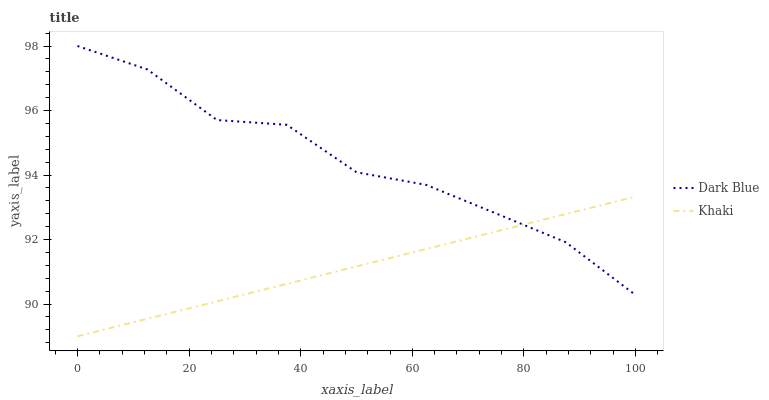Does Khaki have the minimum area under the curve?
Answer yes or no. Yes. Does Dark Blue have the maximum area under the curve?
Answer yes or no. Yes. Does Khaki have the maximum area under the curve?
Answer yes or no. No. Is Khaki the smoothest?
Answer yes or no. Yes. Is Dark Blue the roughest?
Answer yes or no. Yes. Is Khaki the roughest?
Answer yes or no. No. Does Khaki have the highest value?
Answer yes or no. No. 